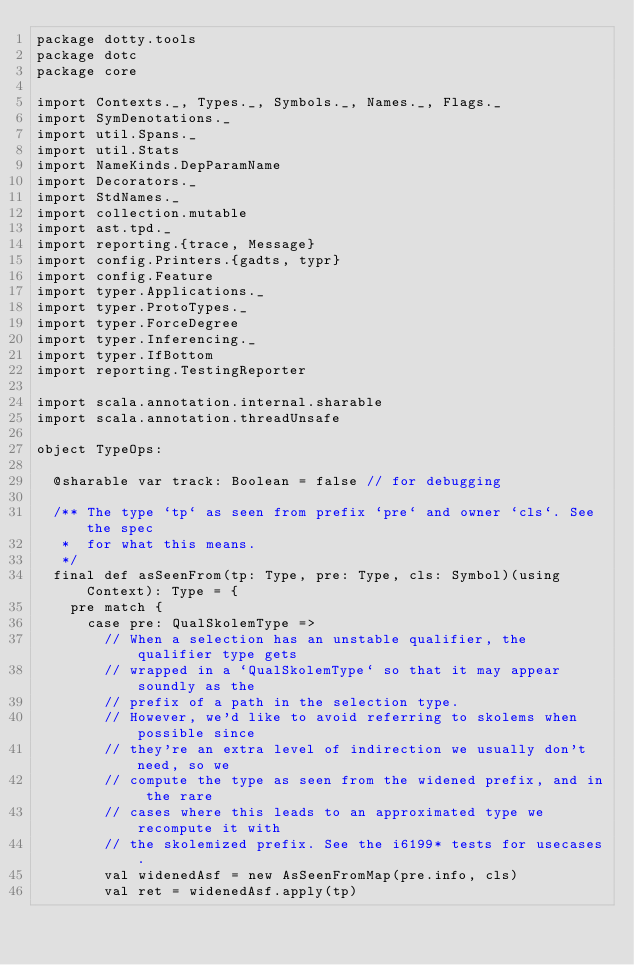Convert code to text. <code><loc_0><loc_0><loc_500><loc_500><_Scala_>package dotty.tools
package dotc
package core

import Contexts._, Types._, Symbols._, Names._, Flags._
import SymDenotations._
import util.Spans._
import util.Stats
import NameKinds.DepParamName
import Decorators._
import StdNames._
import collection.mutable
import ast.tpd._
import reporting.{trace, Message}
import config.Printers.{gadts, typr}
import config.Feature
import typer.Applications._
import typer.ProtoTypes._
import typer.ForceDegree
import typer.Inferencing._
import typer.IfBottom
import reporting.TestingReporter

import scala.annotation.internal.sharable
import scala.annotation.threadUnsafe

object TypeOps:

  @sharable var track: Boolean = false // for debugging

  /** The type `tp` as seen from prefix `pre` and owner `cls`. See the spec
   *  for what this means.
   */
  final def asSeenFrom(tp: Type, pre: Type, cls: Symbol)(using Context): Type = {
    pre match {
      case pre: QualSkolemType =>
        // When a selection has an unstable qualifier, the qualifier type gets
        // wrapped in a `QualSkolemType` so that it may appear soundly as the
        // prefix of a path in the selection type.
        // However, we'd like to avoid referring to skolems when possible since
        // they're an extra level of indirection we usually don't need, so we
        // compute the type as seen from the widened prefix, and in the rare
        // cases where this leads to an approximated type we recompute it with
        // the skolemized prefix. See the i6199* tests for usecases.
        val widenedAsf = new AsSeenFromMap(pre.info, cls)
        val ret = widenedAsf.apply(tp)
</code> 